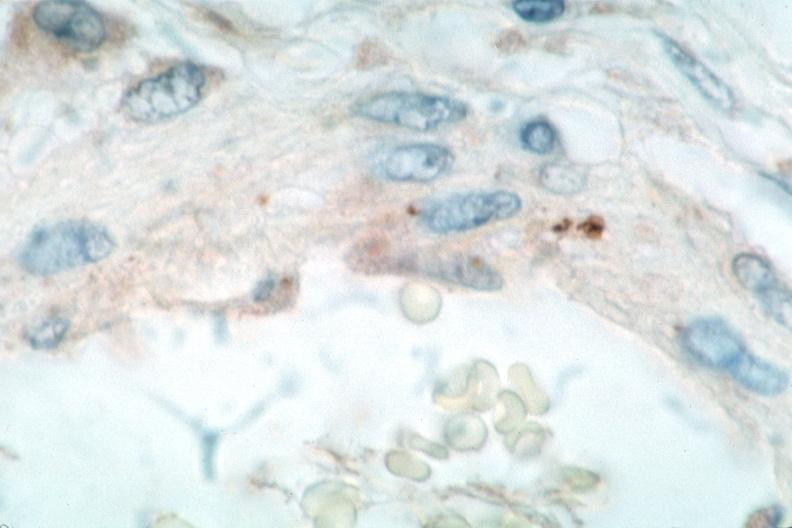what spotted fever, immunoperoxidase staining vessels for rickettsia rickettsii?
Answer the question using a single word or phrase. Rocky mountain 